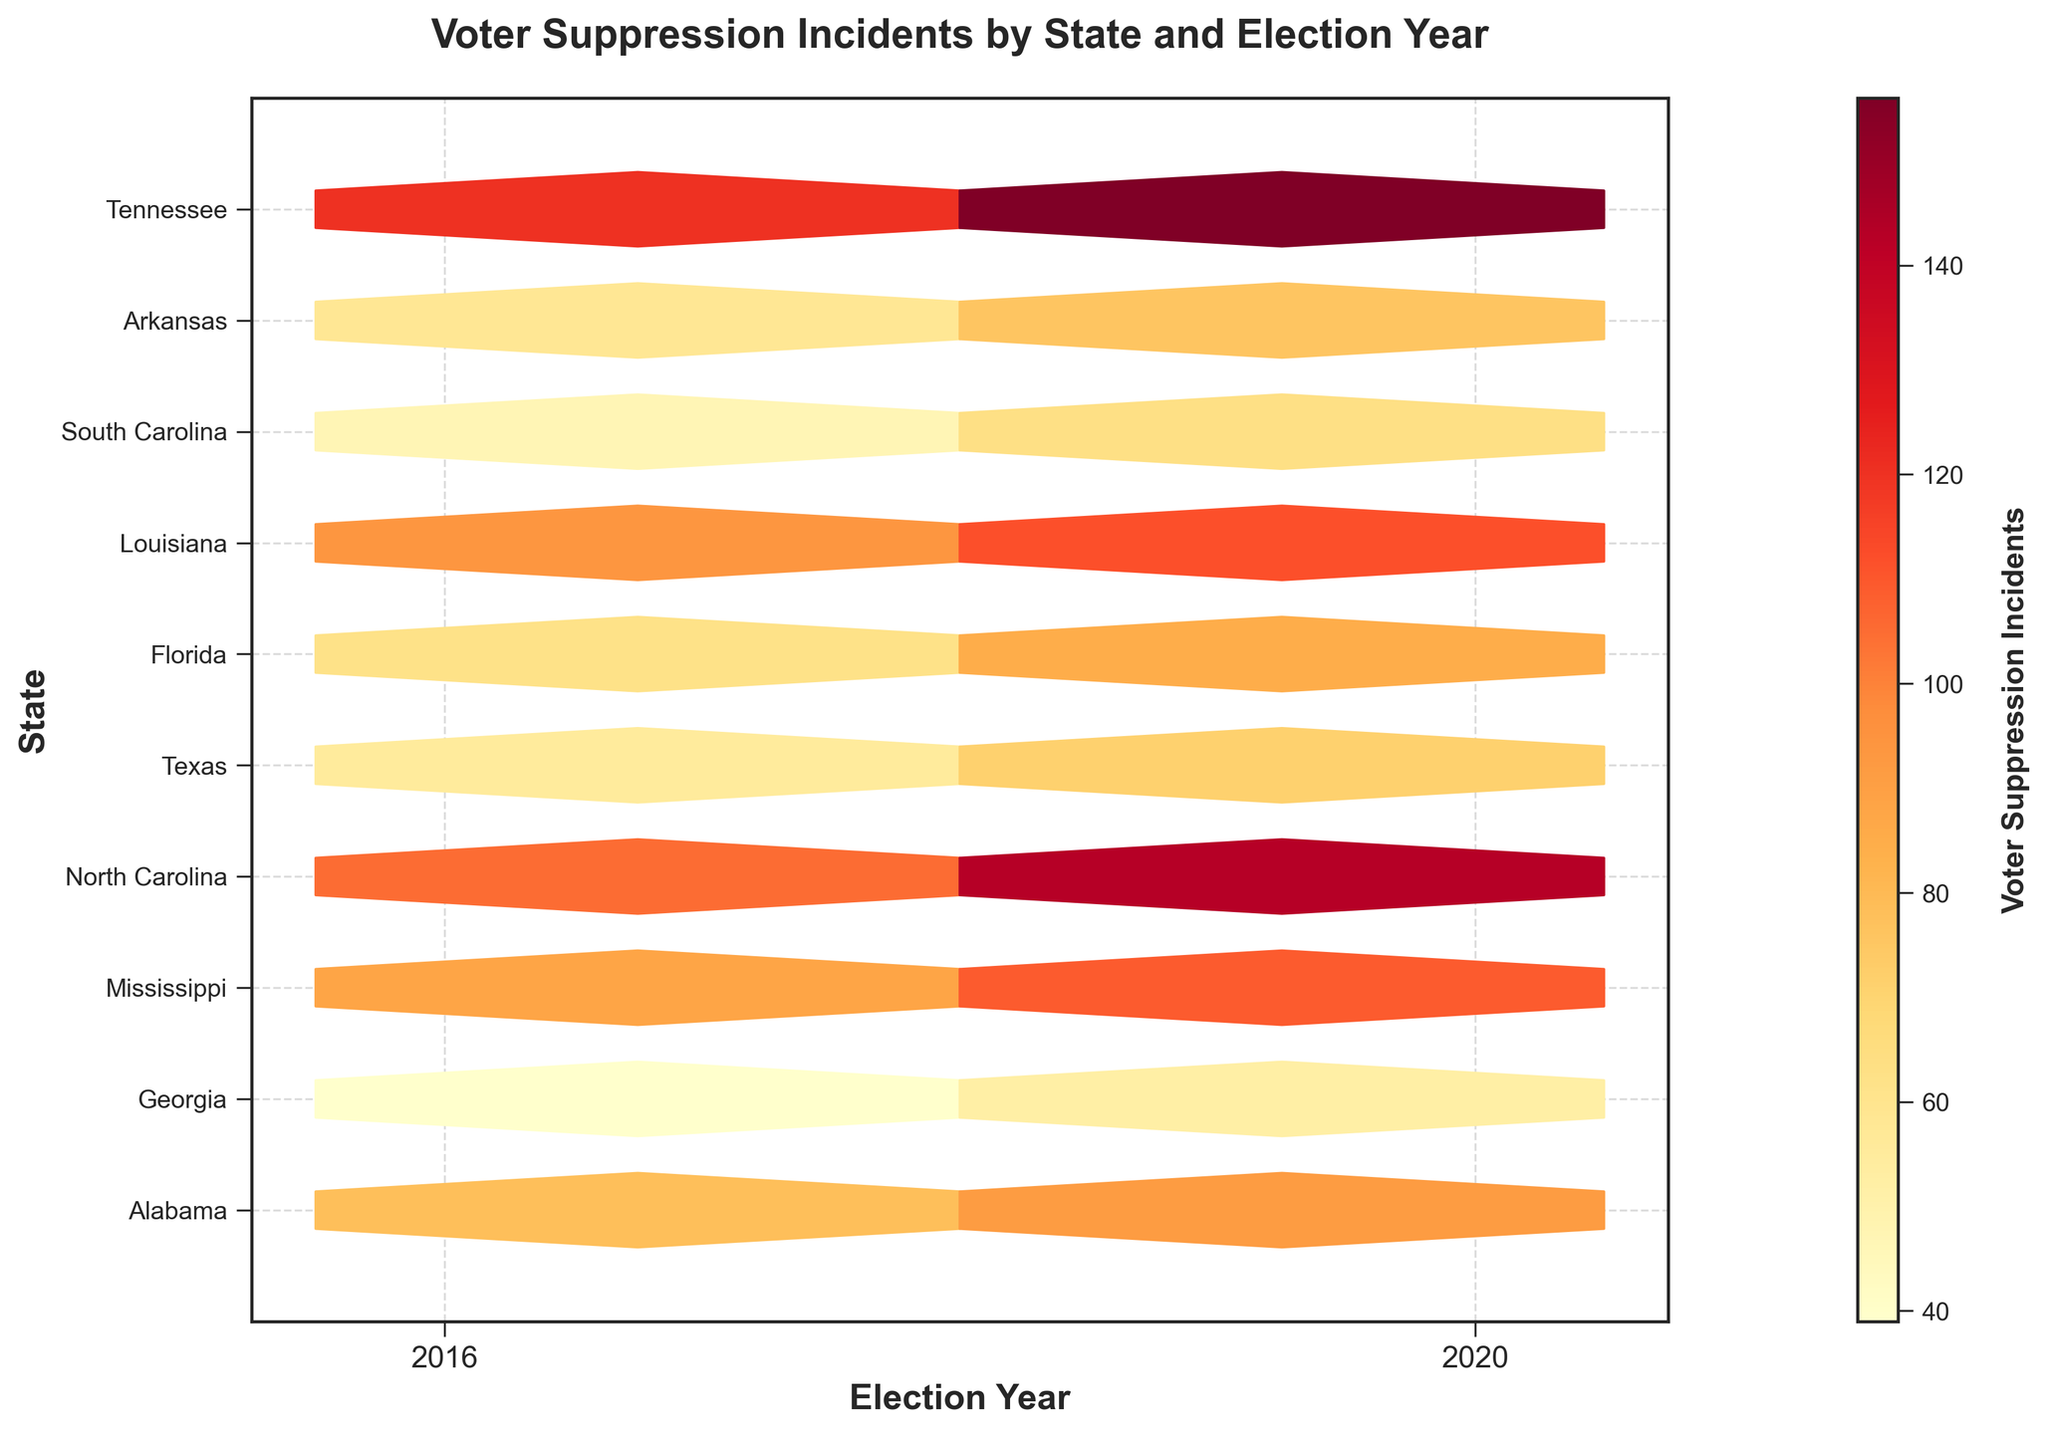What is the title of the hexbin plot? The title of the hexbin plot is located at the top center of the figure. It is written in bold and provides a summary of what the plot is about.
Answer: Voter Suppression Incidents by State and Election Year How many total states are represented on the hexbin plot? To determine the number of states, one must count the distinct labels on the y-axis. Each unique label represents a different state.
Answer: 10 Which state had the highest number of voter suppression incidents in 2020? By looking at the hexbin color, the state with the darkest hexagon in 2020 will indicate the highest number of incidents.
Answer: Texas Compare Alabama in 2016 and 2020. By how much did voter suppression incidents change? Find the corresponding hexes for Alabama in 2016 and 2020 and compare their color intensities. The color bar helps estimate the number of incidents. Subtract the 2016 value from the 2020 value.
Answer: 14 Which year overall appears to have more voter suppression incidents, 2016 or 2020? Observe and compare the color intensities of the hexagons for 2016 and 2020. The year with more overall darker hexagons indicates more voter suppression incidents.
Answer: 2020 What is the color gradient used to represent voter suppression incidents? Look at the color bar to the right of the plot. It shows a gradient scale starting from one color and ending in another, representing the range of voter suppression incidents.
Answer: Yellows to Oranges to Reds Which state shows the least voter suppression incidents in the year 2016 and what is that number? The state with the lightest colored hexagon in 2016 represents the least incidents. Check the color bar to estimate the number.
Answer: Arkansas, 39 Is there any state that showed a reduction in voter suppression incidents from 2016 to 2020? Review the hexagons side by side for any state over both years where the color lightens from 2016 to 2020, indicating a reduction in incidents.
Answer: No On average, are the voter suppression incidents in Southern states higher than those in other states? Identify and compare the color intensities for Southern states (e.g., Georgia, Alabama, Mississippi) versus the others on both axes. Review color bar estimates for average evaluation.
Answer: Yes Which states are on the plot and are not typically considered Southern states? Cross-reference the y-axis labels with common Southern states to identify any which are not typical.
Answer: Arkansas, Louisiana, Tennessee 